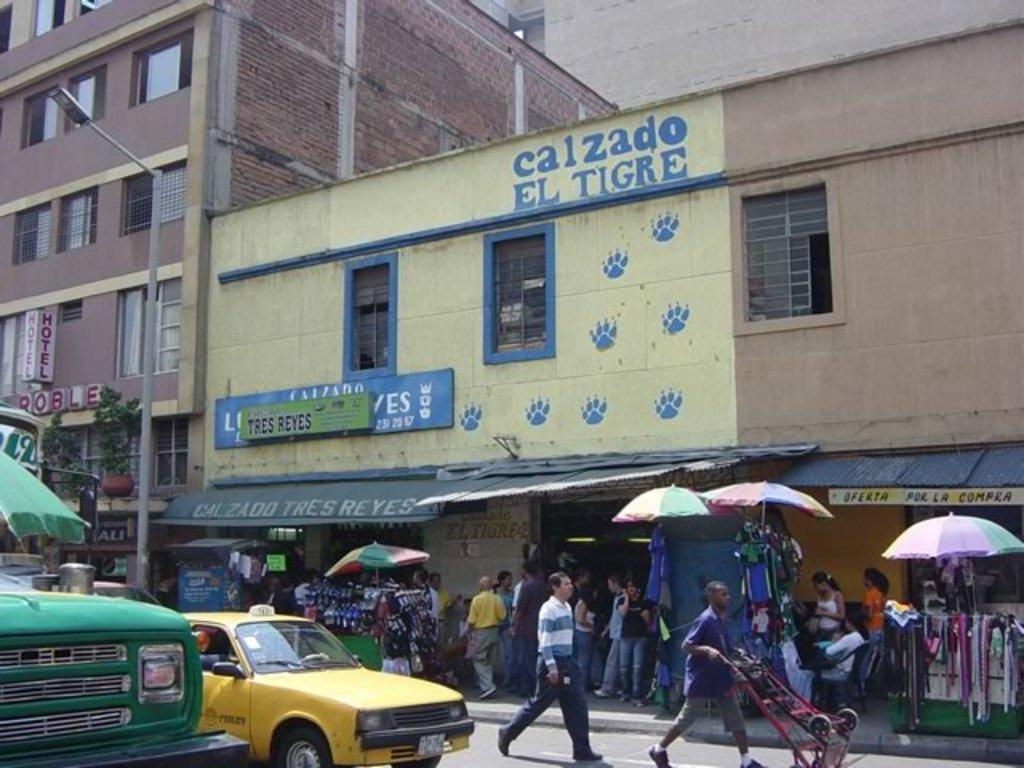<image>
Offer a succinct explanation of the picture presented. People are walking through a street next to a building with Calzado El Tigre sign. 